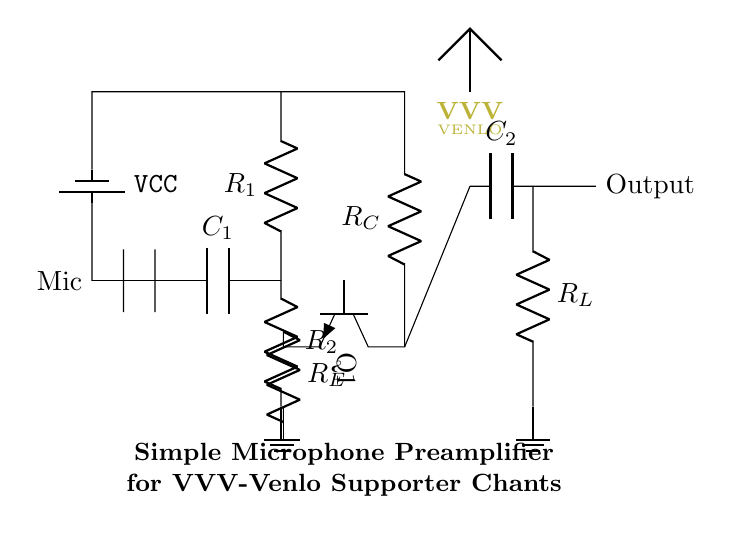What is the component used to couple the microphone? The microphone is coupled to the circuit through a capacitor labeled C1. Coupling capacitors are used to isolate different stages of a circuit while allowing AC signals to pass through. In this case, C1 allows the audio signals from the microphone to pass to the next stage while blocking any DC offset.
Answer: C1 What is the type of transistor shown in the circuit? The transistor shown in the circuit is an NPN transistor, indicated by the symbol used (Q1). NPN transistors are commonly used in amplifier circuits due to their ability to effectively amplify electrical signals.
Answer: NPN How many resistors are present in the circuit? The circuit contains four resistors, labeled R1, R2, RE, and RC. Each resistor plays a critical role in setting the bias point for the transistor and determining the overall gain of the amplifier circuit.
Answer: 4 What is the purpose of resistor RE in this circuit? Resistor RE, or the emitter resistor, is used to stabilize the operating point of the transistor. It provides negative feedback, which helps maintain consistent performance despite variations in temperature or power supply voltages. A well-chosen emitter resistor enhances linearity and reduces distortion in the amplified signal.
Answer: Stabilization What is the output component listed in the diagram? The output component listed in the diagram is a coupling capacitor labeled C2. This component is placed at the output stage to transfer the amplified audio signal while blocking any DC voltage present, ensuring that only the AC component of the signal is sent to the next stage or load.
Answer: C2 What is the purpose of the power supply labeled VCC? VCC is the supply voltage providing the necessary power for the circuit and allows the transistor to operate in the active region, enabling amplification. It is a crucial component for the functionality of the amplifier, providing the energy needed for the signal processing.
Answer: Power supply What type of circuit is depicted in the diagram? The circuit depicted is a simple microphone preamplifier. The purpose of this circuit is to take the low-level audio signals generated by the microphone and amplify them to a higher voltage suitable for further processing or amplification. This is essential for effectively capturing supporter chants.
Answer: Microphone preamplifier 